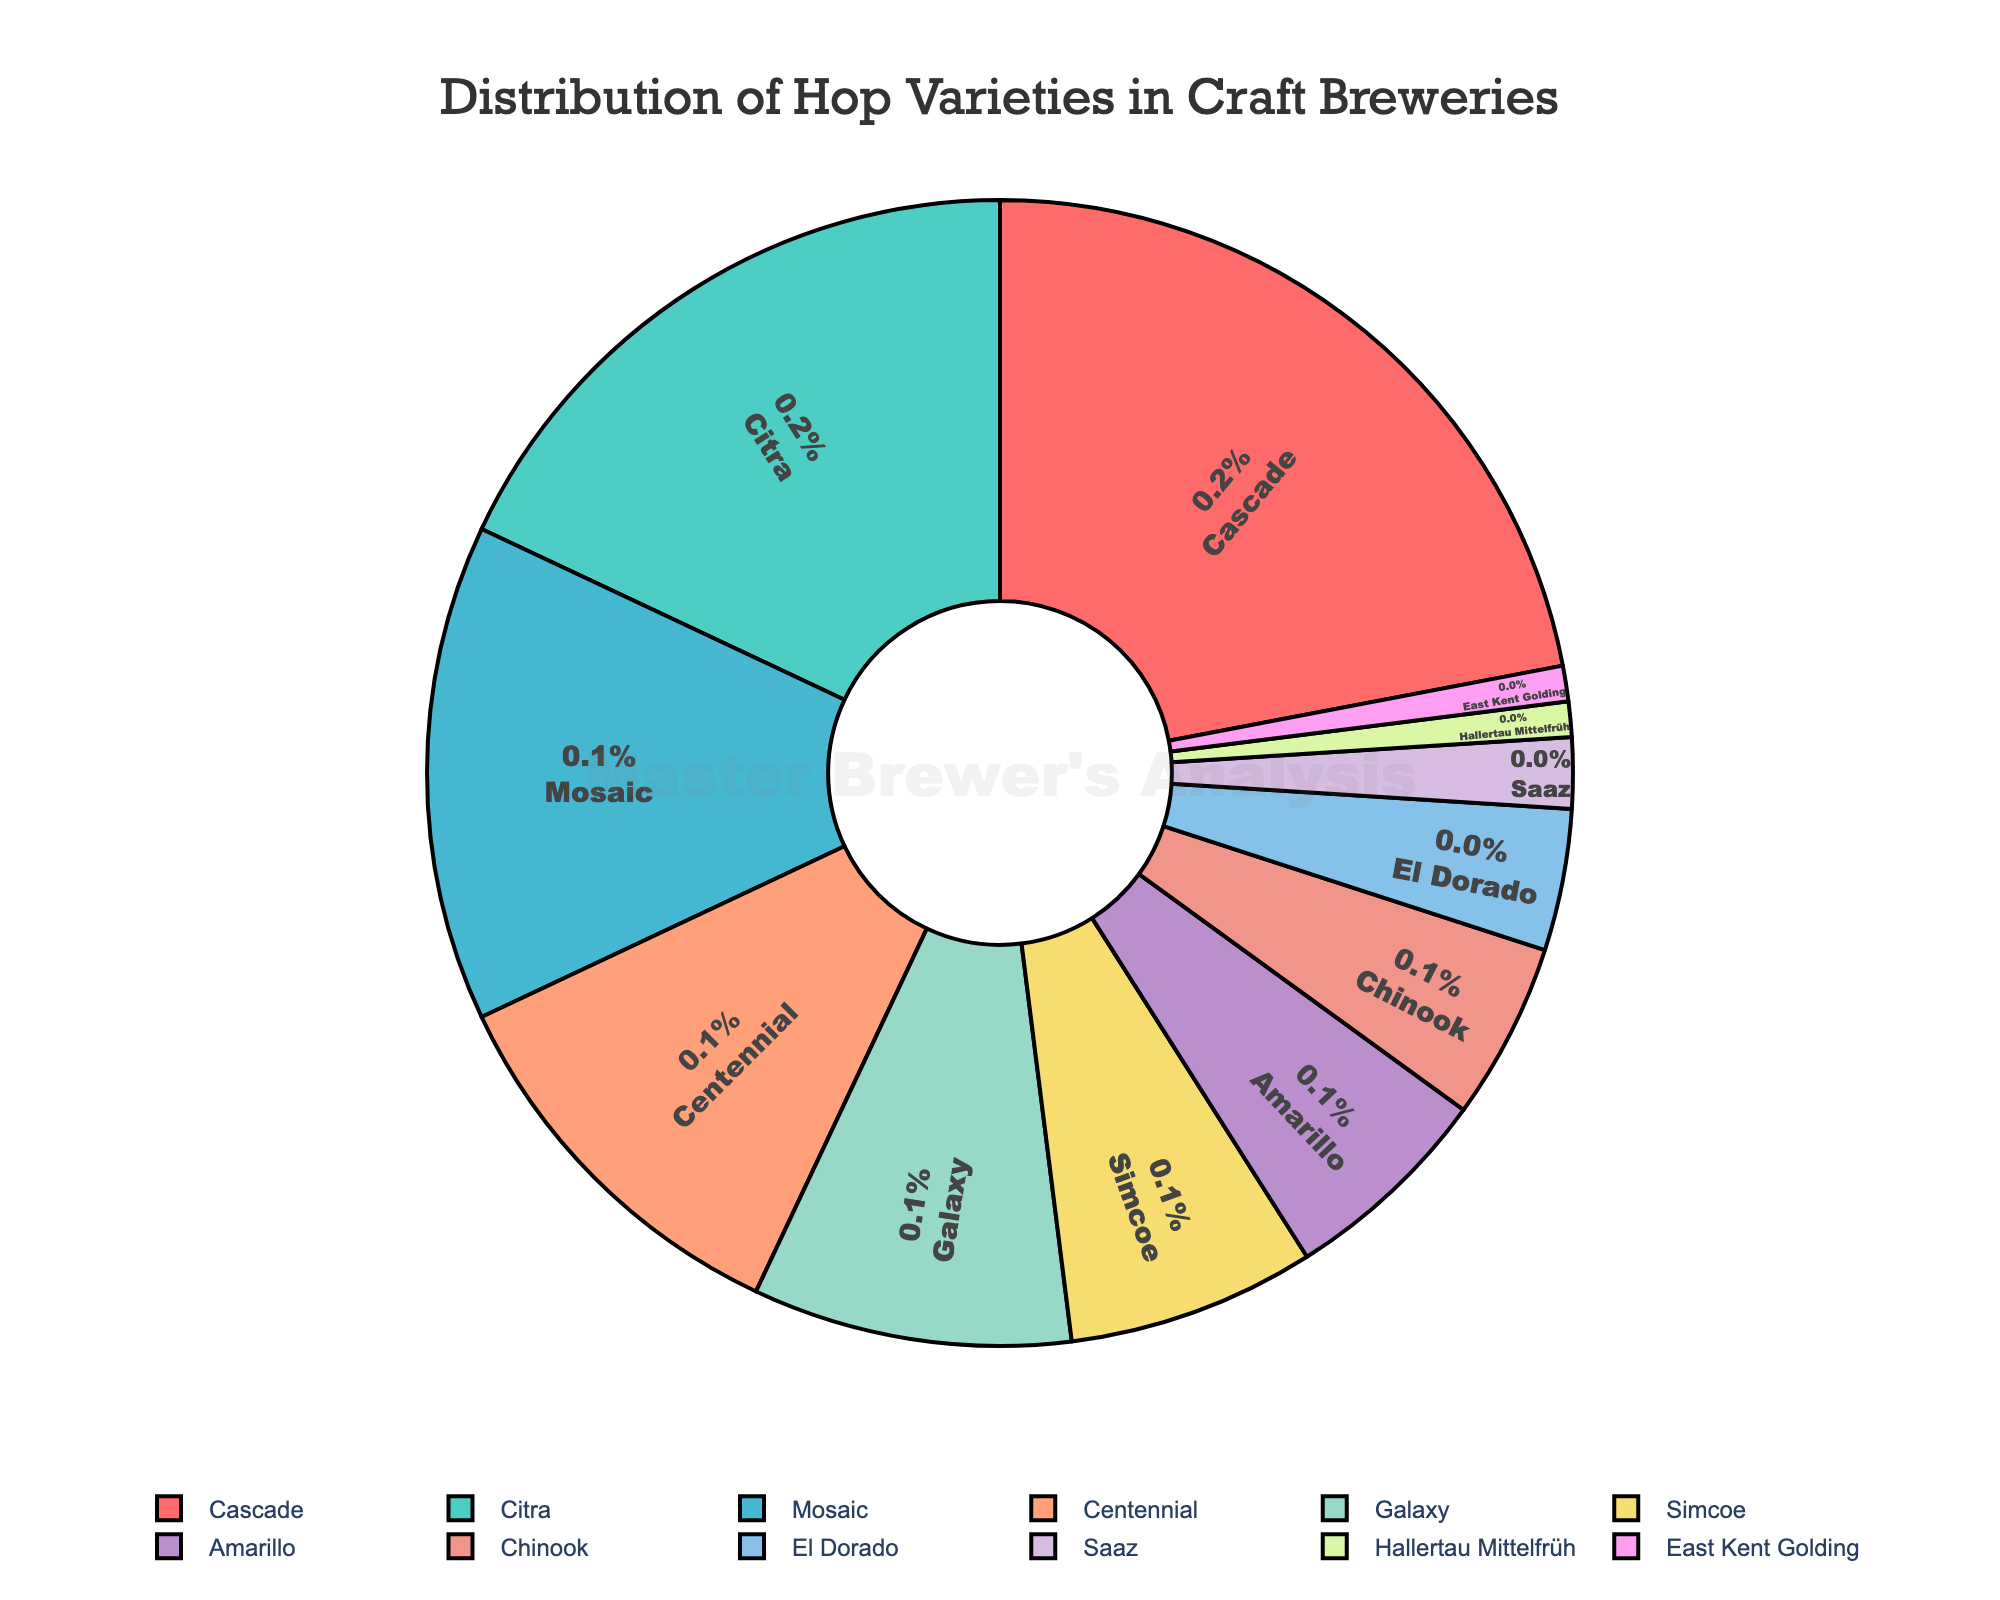Which hop variety is used the most? The figure shows the percentages of different hop varieties. The one with the highest percentage is used the most. Cascade has the highest percentage at 22%.
Answer: Cascade Which hop variety is used the least? The figure shows the percentages of different hop varieties. The one with the lowest percentage is used the least. Both Hallertau Mittelfrüh and East Kent Golding have the lowest percentage at 1%.
Answer: Hallertau Mittelfrüh and East Kent Golding What is the total percentage of Cascade, Citra, and Mosaic combined? To get the total percentage, add the individual percentages of Cascade (22%), Citra (18%), and Mosaic (14%). Thus, 22% + 18% + 14% = 54%.
Answer: 54% How much more popular is Cascade compared to Galaxy? The figure indicates that Cascade has 22% and Galaxy has 9%. Subtract Galaxy's percentage from Cascade's to find the difference: 22% - 9% = 13%.
Answer: 13% Which two hop varieties together make up exactly 20% of the distribution? From the figure, Simcoe has 7%, Amarillo has 6%, and Chinook has 5%. Adding Simcoe (7%) and Amarillo (6%) gives 13%, Simcoe (7%) and Chinook (5%) gives 12%, and Amarillo (6%) and Chinook (5%) gives 11%. However, Saaz has 2% and Hallertau Mittelfrüh has 1%. Combining East Kent Golding (1%) and Hallertau Mittelfrüh (1%) gives 2%, so none add up to exactly 20%. However, El Dorado (4%) and Chinook (5%) add up to 9%. None precisely add to 20%.
Answer: No combination adds to exactly 20% What percentage more of the total hop varieties does Citra have compared to Simcoe? The figure shows that Citra has 18% while Simcoe has 7%. Subtract Simcoe's percentage from Citra's to determine the difference: 18% - 7% = 11%.
Answer: 11% Which hop varieties are in the top three by total percentage? By examining the figure, the three varieties with the highest percentages are Cascade (22%), Citra (18%), and Mosaic (14%).
Answer: Cascade, Citra, Mosaic Does Centennial make up more or less than 10% of the total distribution of hop varieties? The figure indicates that Centennial makes up 11%. This is more than 10%.
Answer: More How much more does Cascade contribute to the distribution compared to Chinook and El Dorado combined? Cascade contributes 22%. Chinook contributes 5%, and El Dorado contributes 4%. Combined, Chinook and El Dorado make up 9%. Subtract their combined percentage from Cascade's: 22% - 9% = 13%.
Answer: 13% 